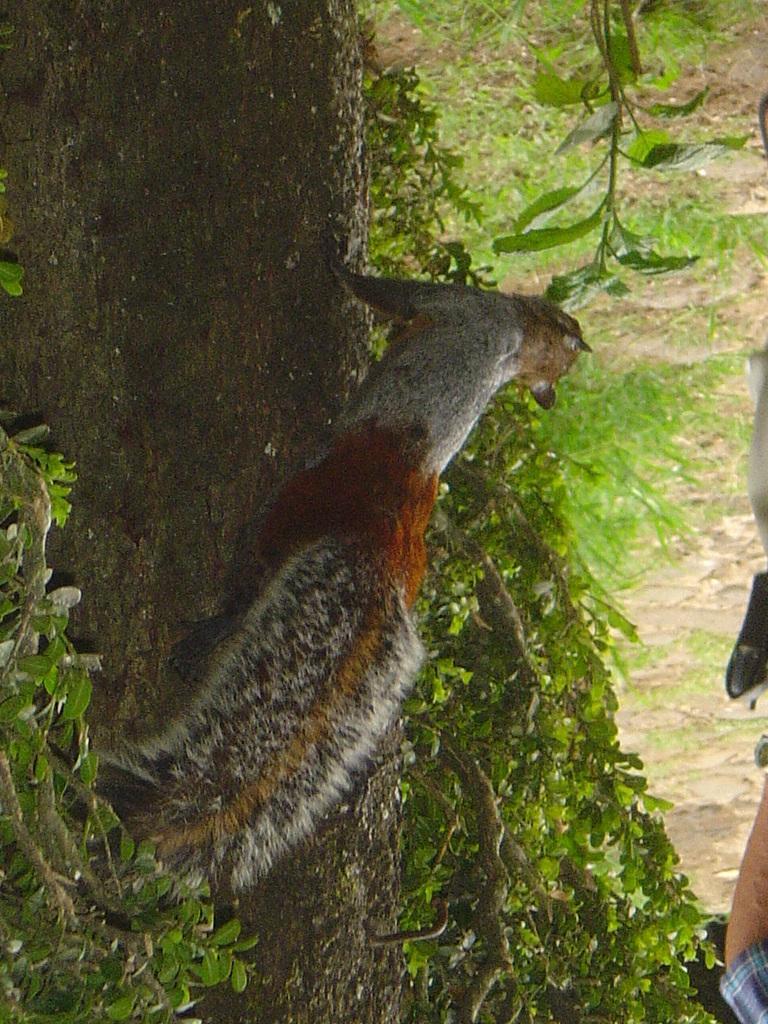Please provide a concise description of this image. In the center of the image we can see an animal is present on the tree. In the background of the image we can see the grass and ground. On the right side of the image we can see a person hand and holding an object. 